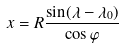<formula> <loc_0><loc_0><loc_500><loc_500>x = R \frac { \sin ( \lambda - \lambda _ { 0 } ) } { \cos \varphi }</formula> 